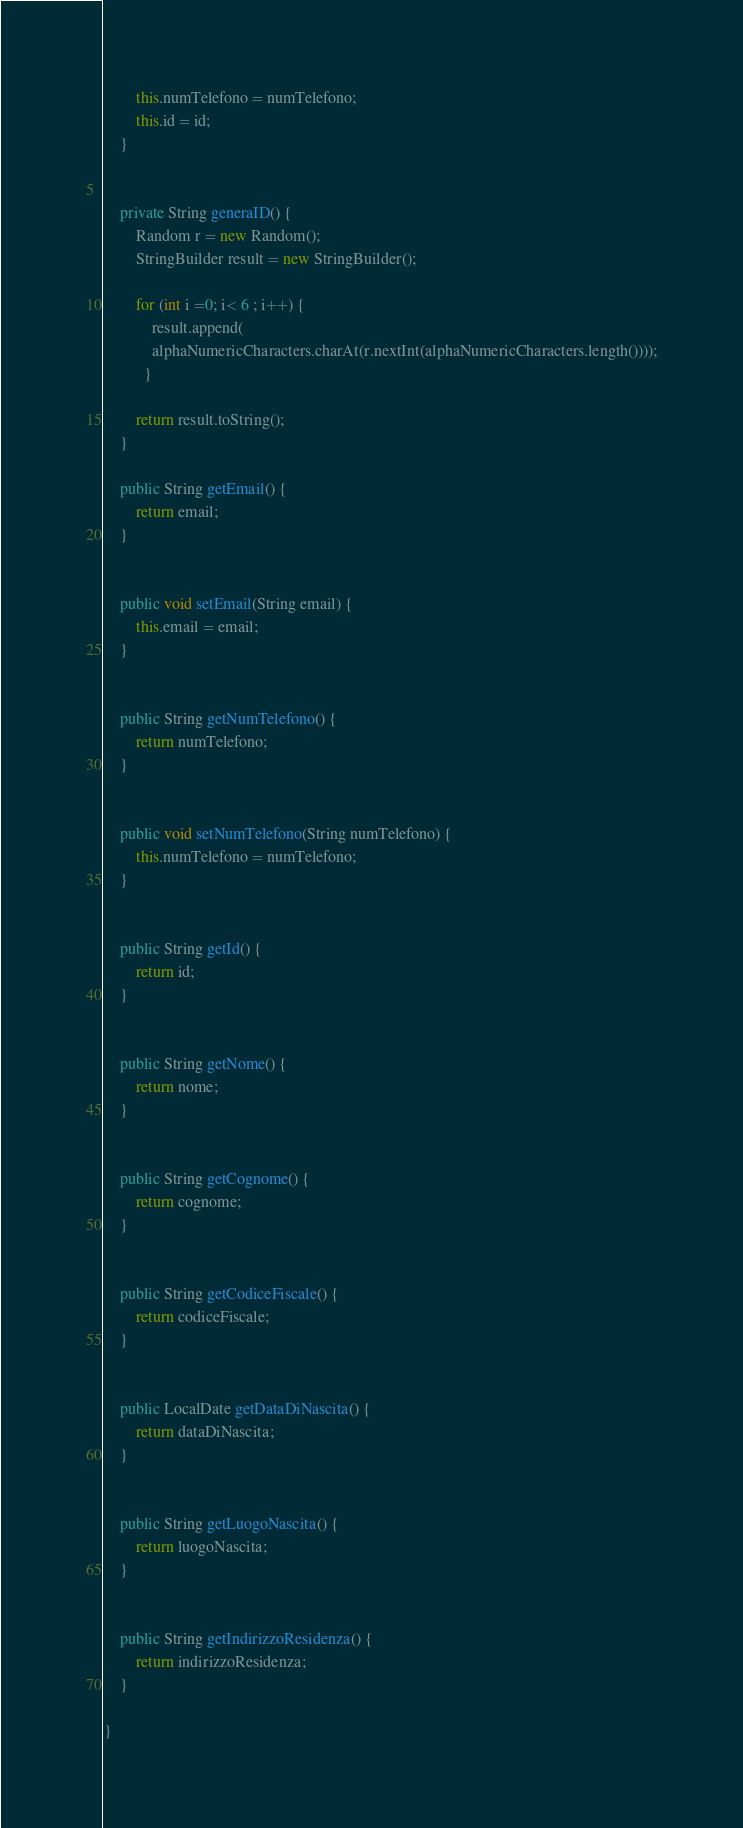<code> <loc_0><loc_0><loc_500><loc_500><_Java_>		this.numTelefono = numTelefono;
		this.id = id;
	}
	
	
	private String generaID() {
		Random r = new Random();
		StringBuilder result = new StringBuilder();
		
		for (int i =0; i< 6 ; i++) {
			result.append(
	        alphaNumericCharacters.charAt(r.nextInt(alphaNumericCharacters.length())));
	      }
		
		return result.toString();
	}

	public String getEmail() {
		return email;
	}


	public void setEmail(String email) {
		this.email = email;
	}


	public String getNumTelefono() {
		return numTelefono;
	}


	public void setNumTelefono(String numTelefono) {
		this.numTelefono = numTelefono;
	}


	public String getId() {
		return id;
	}


	public String getNome() {
		return nome;
	}


	public String getCognome() {
		return cognome;
	}


	public String getCodiceFiscale() {
		return codiceFiscale;
	}


	public LocalDate getDataDiNascita() {
		return dataDiNascita;
	}


	public String getLuogoNascita() {
		return luogoNascita;
	}


	public String getIndirizzoResidenza() {
		return indirizzoResidenza;
	}
	
}
</code> 